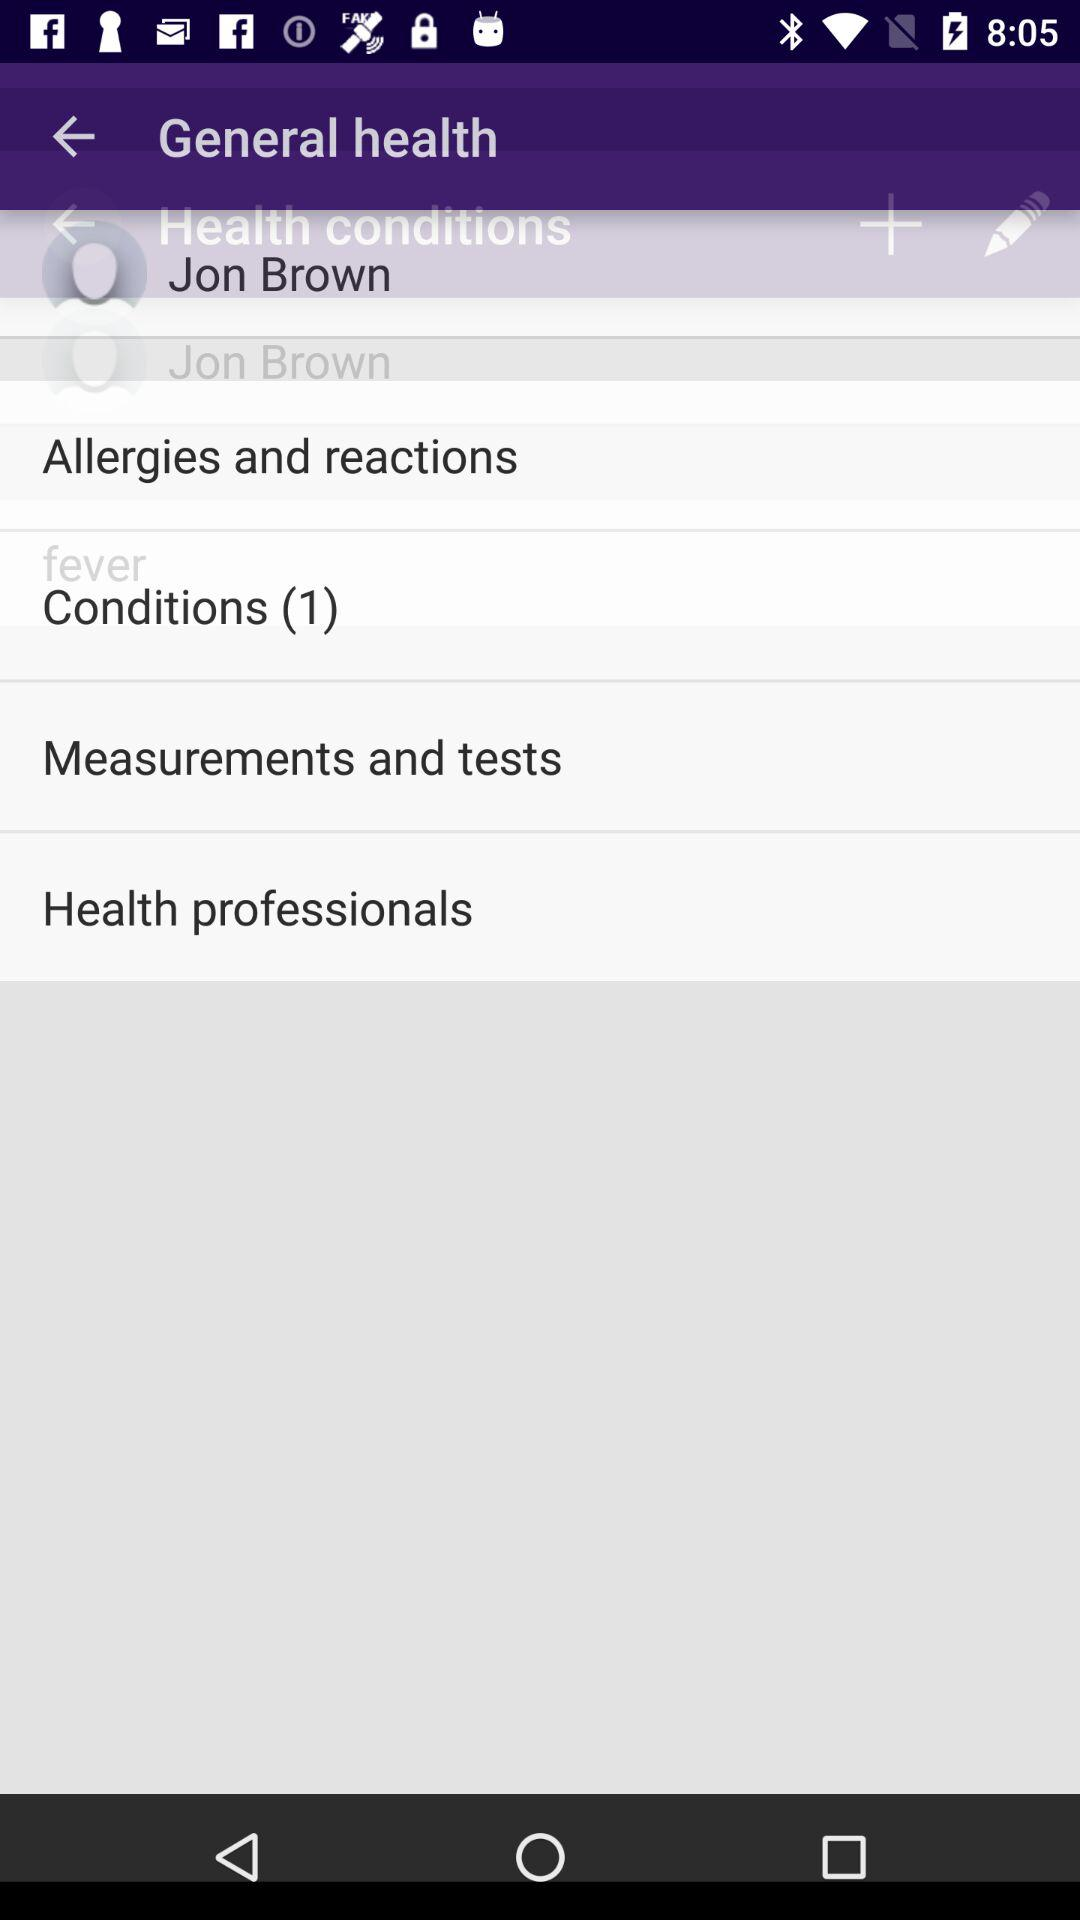What is the number of items in "Conditions"? The number of items in "Conditions" is 1. 